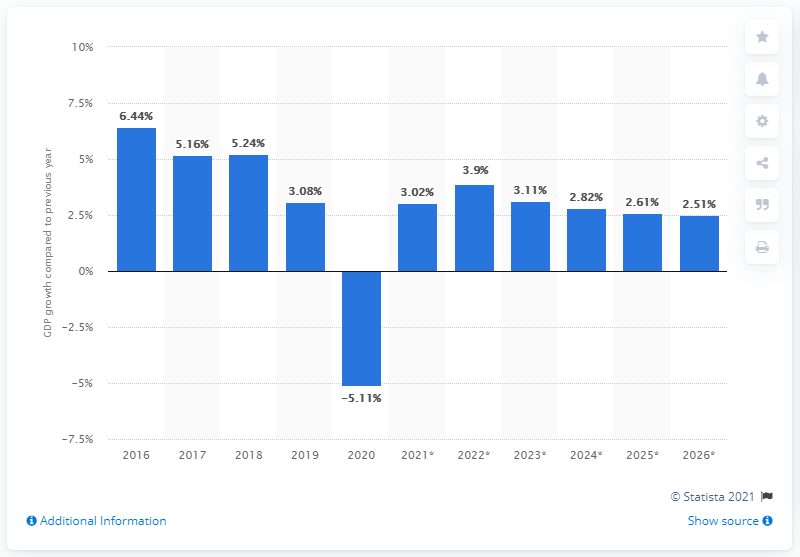Point out several critical features in this image. Cyprus' real gross domestic product decreased by 5.16% in 2020. 